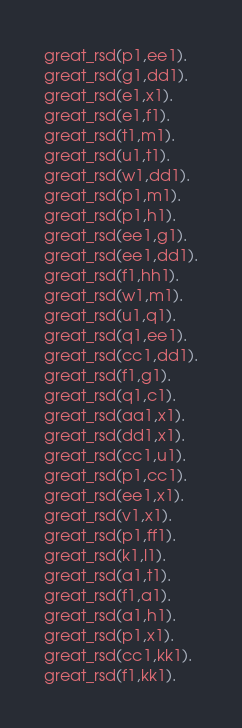Convert code to text. <code><loc_0><loc_0><loc_500><loc_500><_FORTRAN_>great_rsd(p1,ee1).
great_rsd(g1,dd1).
great_rsd(e1,x1).
great_rsd(e1,f1).
great_rsd(t1,m1).
great_rsd(u1,t1).
great_rsd(w1,dd1).
great_rsd(p1,m1).
great_rsd(p1,h1).
great_rsd(ee1,g1).
great_rsd(ee1,dd1).
great_rsd(f1,hh1).
great_rsd(w1,m1).
great_rsd(u1,q1).
great_rsd(q1,ee1).
great_rsd(cc1,dd1).
great_rsd(f1,g1).
great_rsd(q1,c1).
great_rsd(aa1,x1).
great_rsd(dd1,x1).
great_rsd(cc1,u1).
great_rsd(p1,cc1).
great_rsd(ee1,x1).
great_rsd(v1,x1).
great_rsd(p1,ff1).
great_rsd(k1,l1).
great_rsd(a1,t1).
great_rsd(f1,a1).
great_rsd(a1,h1).
great_rsd(p1,x1).
great_rsd(cc1,kk1).
great_rsd(f1,kk1).
</code> 